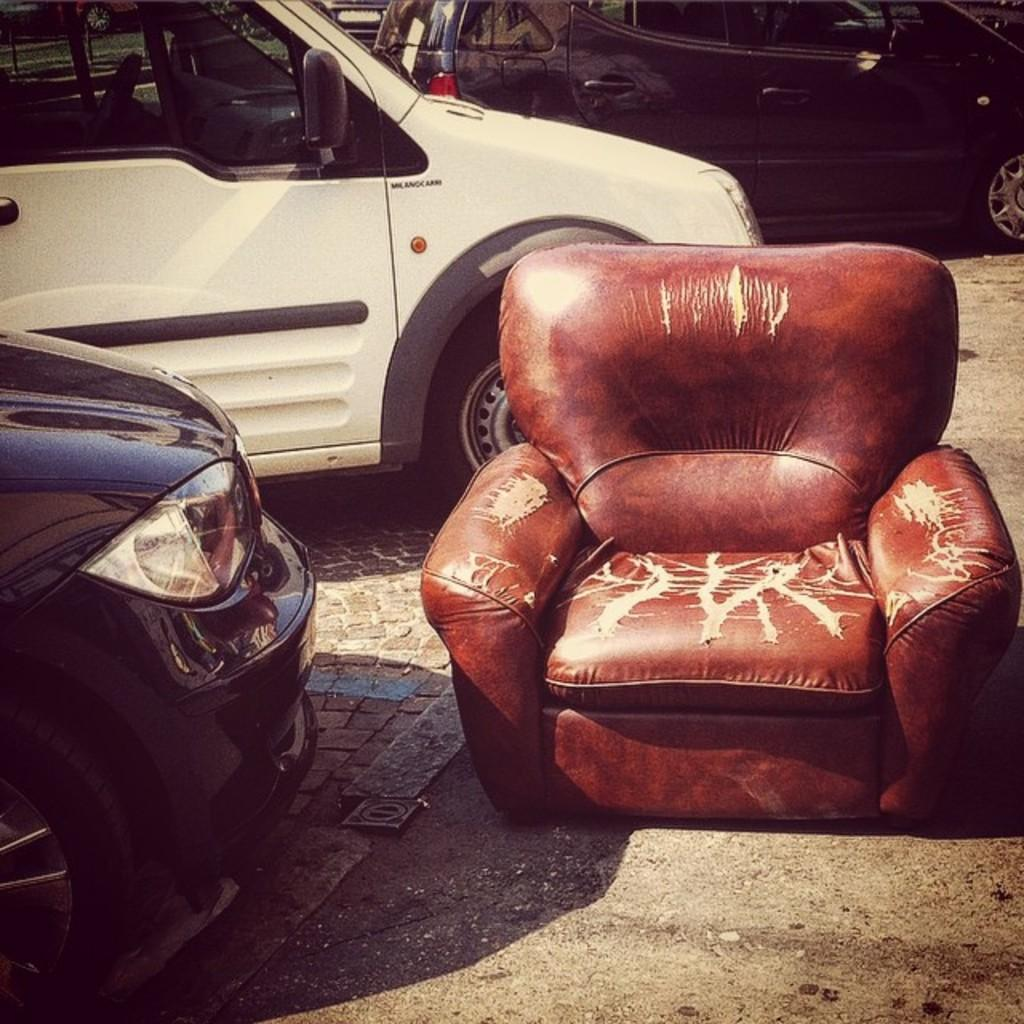What type of furniture is present in the image? There is a chair in the image. What vehicles can be seen in the image? There are three cars parked in the image. What type of wire can be seen connecting the cars in the image? There is no wire connecting the cars in the image; they are parked separately. Is there a stranger present in the image? There is no mention of a stranger in the image, so we cannot determine if one is present or not. 